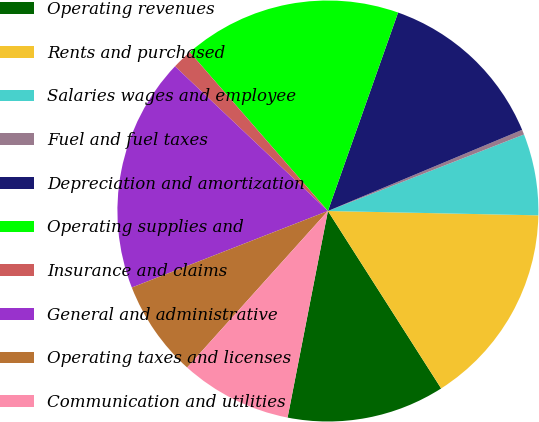Convert chart. <chart><loc_0><loc_0><loc_500><loc_500><pie_chart><fcel>Operating revenues<fcel>Rents and purchased<fcel>Salaries wages and employee<fcel>Fuel and fuel taxes<fcel>Depreciation and amortization<fcel>Operating supplies and<fcel>Insurance and claims<fcel>General and administrative<fcel>Operating taxes and licenses<fcel>Communication and utilities<nl><fcel>12.11%<fcel>15.63%<fcel>6.25%<fcel>0.38%<fcel>13.29%<fcel>16.8%<fcel>1.55%<fcel>17.98%<fcel>7.42%<fcel>8.59%<nl></chart> 